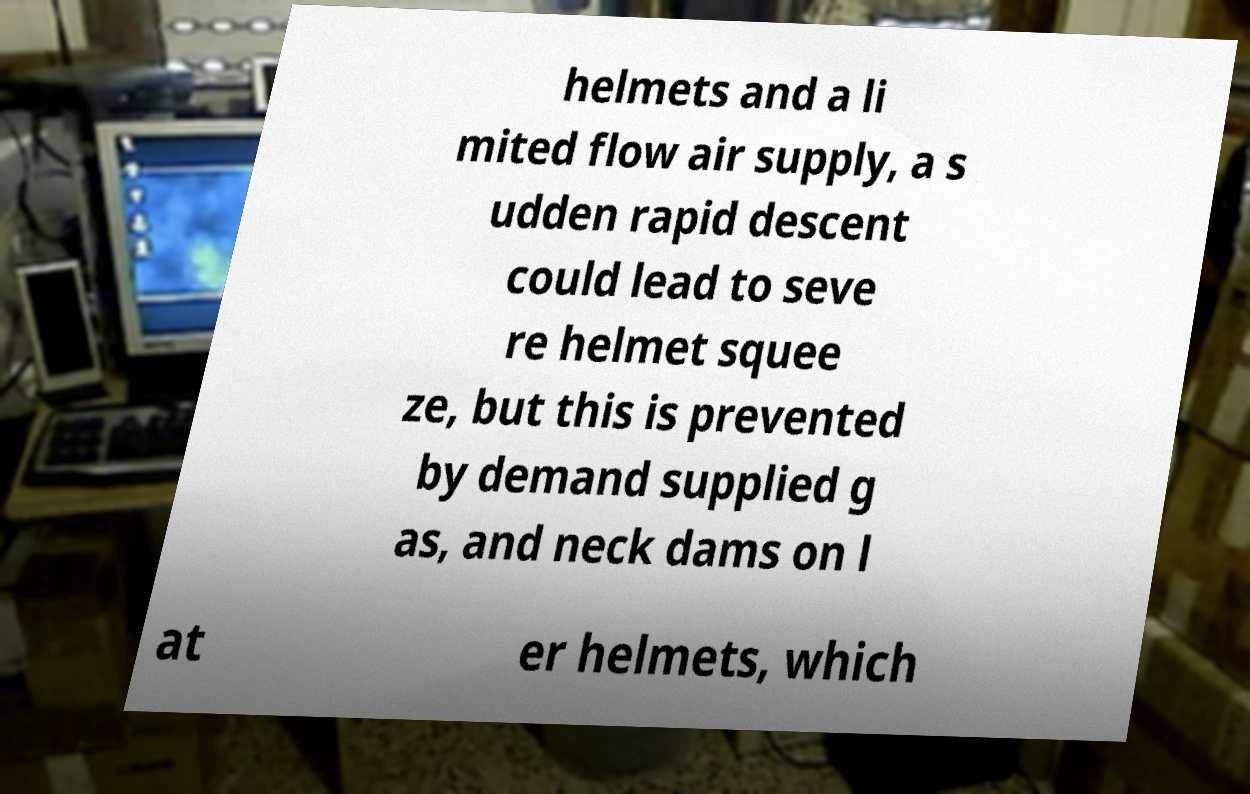Can you accurately transcribe the text from the provided image for me? helmets and a li mited flow air supply, a s udden rapid descent could lead to seve re helmet squee ze, but this is prevented by demand supplied g as, and neck dams on l at er helmets, which 